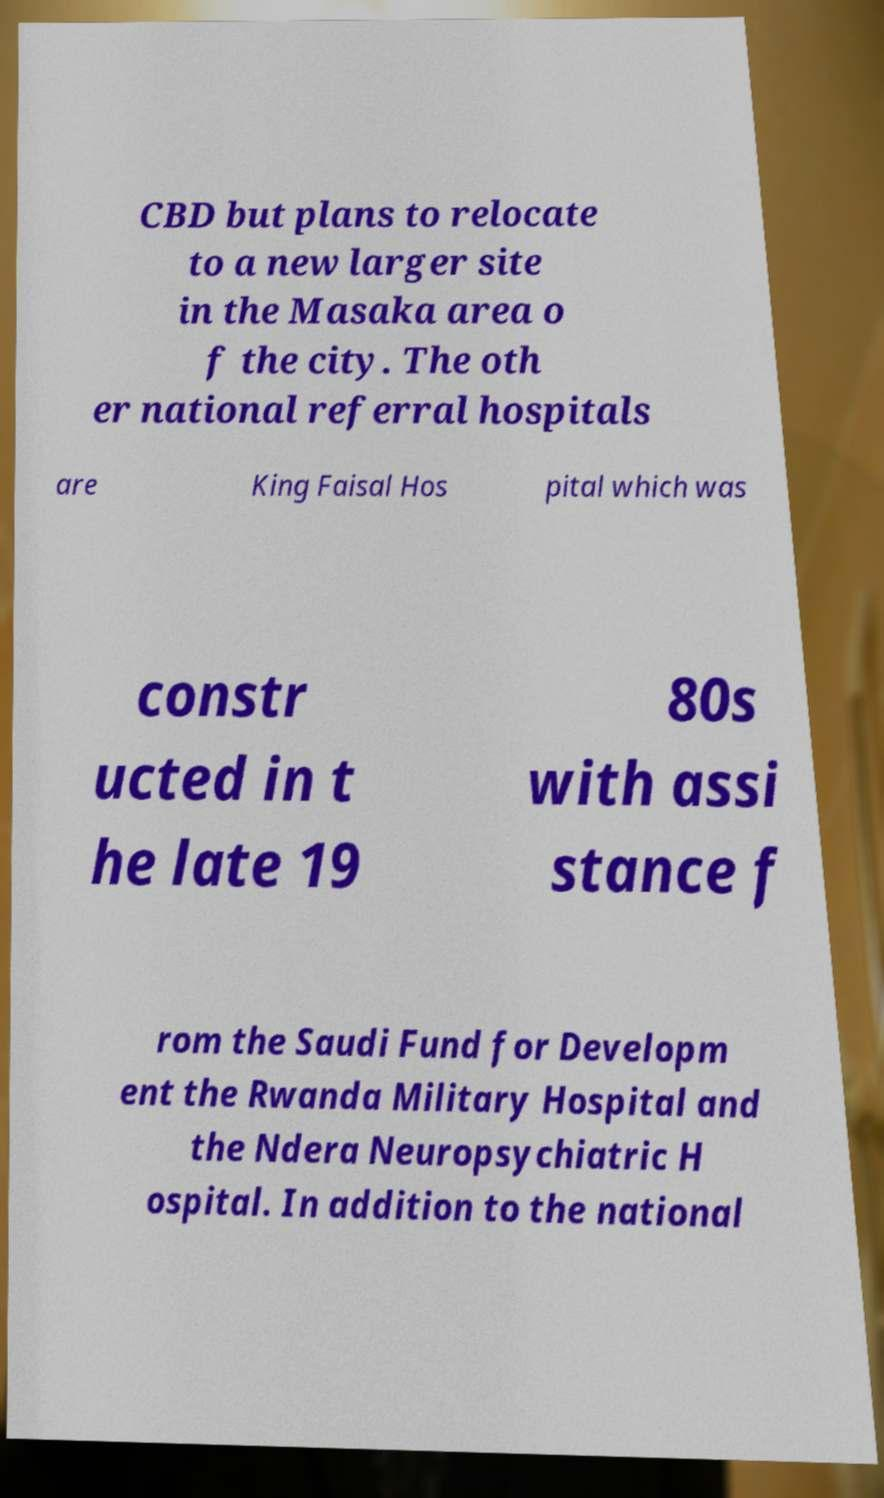Could you assist in decoding the text presented in this image and type it out clearly? CBD but plans to relocate to a new larger site in the Masaka area o f the city. The oth er national referral hospitals are King Faisal Hos pital which was constr ucted in t he late 19 80s with assi stance f rom the Saudi Fund for Developm ent the Rwanda Military Hospital and the Ndera Neuropsychiatric H ospital. In addition to the national 